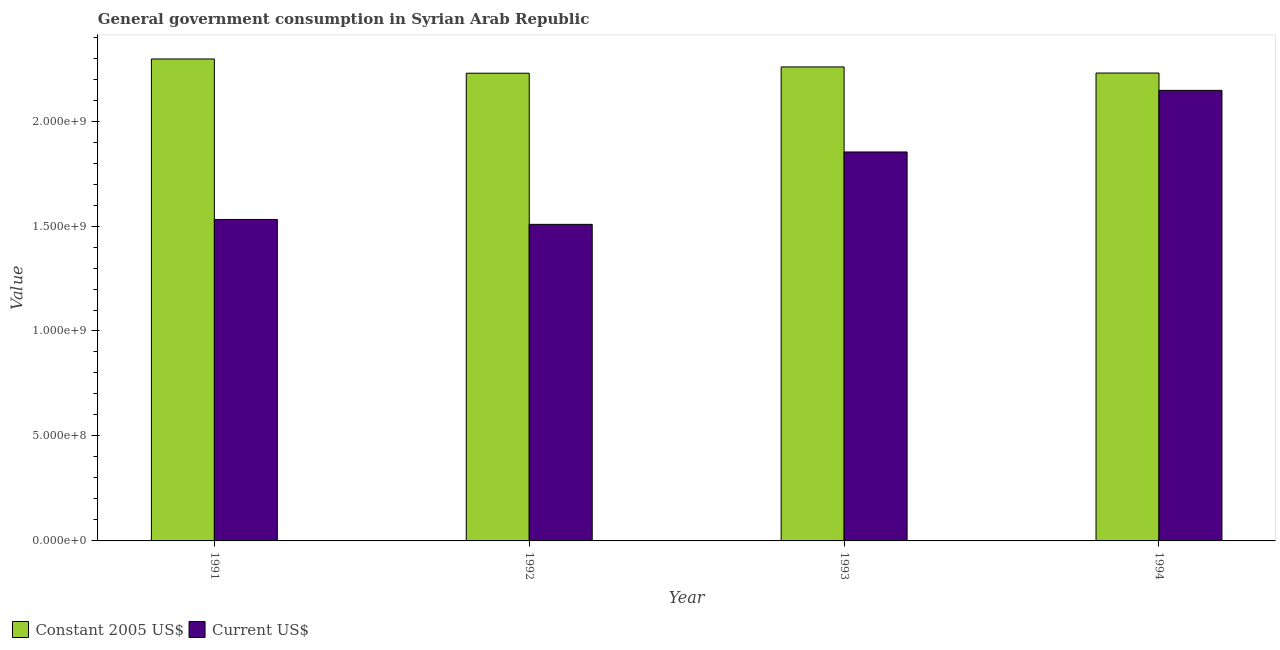How many different coloured bars are there?
Your response must be concise. 2. How many groups of bars are there?
Ensure brevity in your answer.  4. Are the number of bars on each tick of the X-axis equal?
Your response must be concise. Yes. What is the label of the 3rd group of bars from the left?
Your response must be concise. 1993. What is the value consumed in current us$ in 1992?
Keep it short and to the point. 1.51e+09. Across all years, what is the maximum value consumed in constant 2005 us$?
Offer a terse response. 2.30e+09. Across all years, what is the minimum value consumed in constant 2005 us$?
Offer a very short reply. 2.23e+09. What is the total value consumed in current us$ in the graph?
Ensure brevity in your answer.  7.04e+09. What is the difference between the value consumed in constant 2005 us$ in 1991 and that in 1993?
Ensure brevity in your answer.  3.79e+07. What is the difference between the value consumed in constant 2005 us$ in 1991 and the value consumed in current us$ in 1994?
Ensure brevity in your answer.  6.70e+07. What is the average value consumed in current us$ per year?
Keep it short and to the point. 1.76e+09. In the year 1994, what is the difference between the value consumed in constant 2005 us$ and value consumed in current us$?
Your answer should be compact. 0. In how many years, is the value consumed in current us$ greater than 1300000000?
Make the answer very short. 4. What is the ratio of the value consumed in constant 2005 us$ in 1993 to that in 1994?
Provide a short and direct response. 1.01. Is the value consumed in current us$ in 1991 less than that in 1992?
Ensure brevity in your answer.  No. What is the difference between the highest and the second highest value consumed in constant 2005 us$?
Ensure brevity in your answer.  3.79e+07. What is the difference between the highest and the lowest value consumed in current us$?
Make the answer very short. 6.38e+08. Is the sum of the value consumed in current us$ in 1992 and 1994 greater than the maximum value consumed in constant 2005 us$ across all years?
Your answer should be compact. Yes. What does the 2nd bar from the left in 1994 represents?
Provide a short and direct response. Current US$. What does the 1st bar from the right in 1993 represents?
Make the answer very short. Current US$. How many bars are there?
Offer a very short reply. 8. Are all the bars in the graph horizontal?
Provide a short and direct response. No. Are the values on the major ticks of Y-axis written in scientific E-notation?
Provide a short and direct response. Yes. Does the graph contain any zero values?
Keep it short and to the point. No. Does the graph contain grids?
Offer a very short reply. No. What is the title of the graph?
Give a very brief answer. General government consumption in Syrian Arab Republic. Does "Lowest 20% of population" appear as one of the legend labels in the graph?
Offer a terse response. No. What is the label or title of the Y-axis?
Make the answer very short. Value. What is the Value of Constant 2005 US$ in 1991?
Provide a short and direct response. 2.30e+09. What is the Value of Current US$ in 1991?
Provide a succinct answer. 1.53e+09. What is the Value in Constant 2005 US$ in 1992?
Ensure brevity in your answer.  2.23e+09. What is the Value in Current US$ in 1992?
Give a very brief answer. 1.51e+09. What is the Value in Constant 2005 US$ in 1993?
Provide a succinct answer. 2.26e+09. What is the Value in Current US$ in 1993?
Your answer should be compact. 1.85e+09. What is the Value of Constant 2005 US$ in 1994?
Make the answer very short. 2.23e+09. What is the Value in Current US$ in 1994?
Offer a very short reply. 2.15e+09. Across all years, what is the maximum Value of Constant 2005 US$?
Make the answer very short. 2.30e+09. Across all years, what is the maximum Value in Current US$?
Make the answer very short. 2.15e+09. Across all years, what is the minimum Value in Constant 2005 US$?
Your answer should be very brief. 2.23e+09. Across all years, what is the minimum Value of Current US$?
Give a very brief answer. 1.51e+09. What is the total Value of Constant 2005 US$ in the graph?
Give a very brief answer. 9.01e+09. What is the total Value of Current US$ in the graph?
Ensure brevity in your answer.  7.04e+09. What is the difference between the Value in Constant 2005 US$ in 1991 and that in 1992?
Offer a very short reply. 6.78e+07. What is the difference between the Value of Current US$ in 1991 and that in 1992?
Make the answer very short. 2.34e+07. What is the difference between the Value in Constant 2005 US$ in 1991 and that in 1993?
Provide a short and direct response. 3.79e+07. What is the difference between the Value of Current US$ in 1991 and that in 1993?
Provide a succinct answer. -3.21e+08. What is the difference between the Value of Constant 2005 US$ in 1991 and that in 1994?
Your answer should be compact. 6.70e+07. What is the difference between the Value of Current US$ in 1991 and that in 1994?
Make the answer very short. -6.15e+08. What is the difference between the Value of Constant 2005 US$ in 1992 and that in 1993?
Your answer should be very brief. -2.99e+07. What is the difference between the Value in Current US$ in 1992 and that in 1993?
Offer a terse response. -3.45e+08. What is the difference between the Value in Constant 2005 US$ in 1992 and that in 1994?
Provide a succinct answer. -8.10e+05. What is the difference between the Value in Current US$ in 1992 and that in 1994?
Keep it short and to the point. -6.38e+08. What is the difference between the Value in Constant 2005 US$ in 1993 and that in 1994?
Ensure brevity in your answer.  2.91e+07. What is the difference between the Value of Current US$ in 1993 and that in 1994?
Offer a very short reply. -2.93e+08. What is the difference between the Value of Constant 2005 US$ in 1991 and the Value of Current US$ in 1992?
Give a very brief answer. 7.88e+08. What is the difference between the Value in Constant 2005 US$ in 1991 and the Value in Current US$ in 1993?
Provide a short and direct response. 4.43e+08. What is the difference between the Value in Constant 2005 US$ in 1991 and the Value in Current US$ in 1994?
Ensure brevity in your answer.  1.50e+08. What is the difference between the Value in Constant 2005 US$ in 1992 and the Value in Current US$ in 1993?
Ensure brevity in your answer.  3.75e+08. What is the difference between the Value of Constant 2005 US$ in 1992 and the Value of Current US$ in 1994?
Ensure brevity in your answer.  8.18e+07. What is the difference between the Value in Constant 2005 US$ in 1993 and the Value in Current US$ in 1994?
Offer a very short reply. 1.12e+08. What is the average Value of Constant 2005 US$ per year?
Offer a terse response. 2.25e+09. What is the average Value of Current US$ per year?
Ensure brevity in your answer.  1.76e+09. In the year 1991, what is the difference between the Value in Constant 2005 US$ and Value in Current US$?
Provide a succinct answer. 7.64e+08. In the year 1992, what is the difference between the Value in Constant 2005 US$ and Value in Current US$?
Keep it short and to the point. 7.20e+08. In the year 1993, what is the difference between the Value of Constant 2005 US$ and Value of Current US$?
Offer a very short reply. 4.05e+08. In the year 1994, what is the difference between the Value in Constant 2005 US$ and Value in Current US$?
Provide a short and direct response. 8.26e+07. What is the ratio of the Value of Constant 2005 US$ in 1991 to that in 1992?
Your response must be concise. 1.03. What is the ratio of the Value of Current US$ in 1991 to that in 1992?
Your answer should be compact. 1.02. What is the ratio of the Value of Constant 2005 US$ in 1991 to that in 1993?
Your response must be concise. 1.02. What is the ratio of the Value in Current US$ in 1991 to that in 1993?
Offer a very short reply. 0.83. What is the ratio of the Value in Constant 2005 US$ in 1991 to that in 1994?
Make the answer very short. 1.03. What is the ratio of the Value in Current US$ in 1991 to that in 1994?
Make the answer very short. 0.71. What is the ratio of the Value of Current US$ in 1992 to that in 1993?
Your answer should be compact. 0.81. What is the ratio of the Value in Constant 2005 US$ in 1992 to that in 1994?
Offer a terse response. 1. What is the ratio of the Value of Current US$ in 1992 to that in 1994?
Provide a succinct answer. 0.7. What is the ratio of the Value in Constant 2005 US$ in 1993 to that in 1994?
Offer a very short reply. 1.01. What is the ratio of the Value of Current US$ in 1993 to that in 1994?
Your answer should be very brief. 0.86. What is the difference between the highest and the second highest Value of Constant 2005 US$?
Make the answer very short. 3.79e+07. What is the difference between the highest and the second highest Value of Current US$?
Your response must be concise. 2.93e+08. What is the difference between the highest and the lowest Value of Constant 2005 US$?
Ensure brevity in your answer.  6.78e+07. What is the difference between the highest and the lowest Value in Current US$?
Provide a short and direct response. 6.38e+08. 